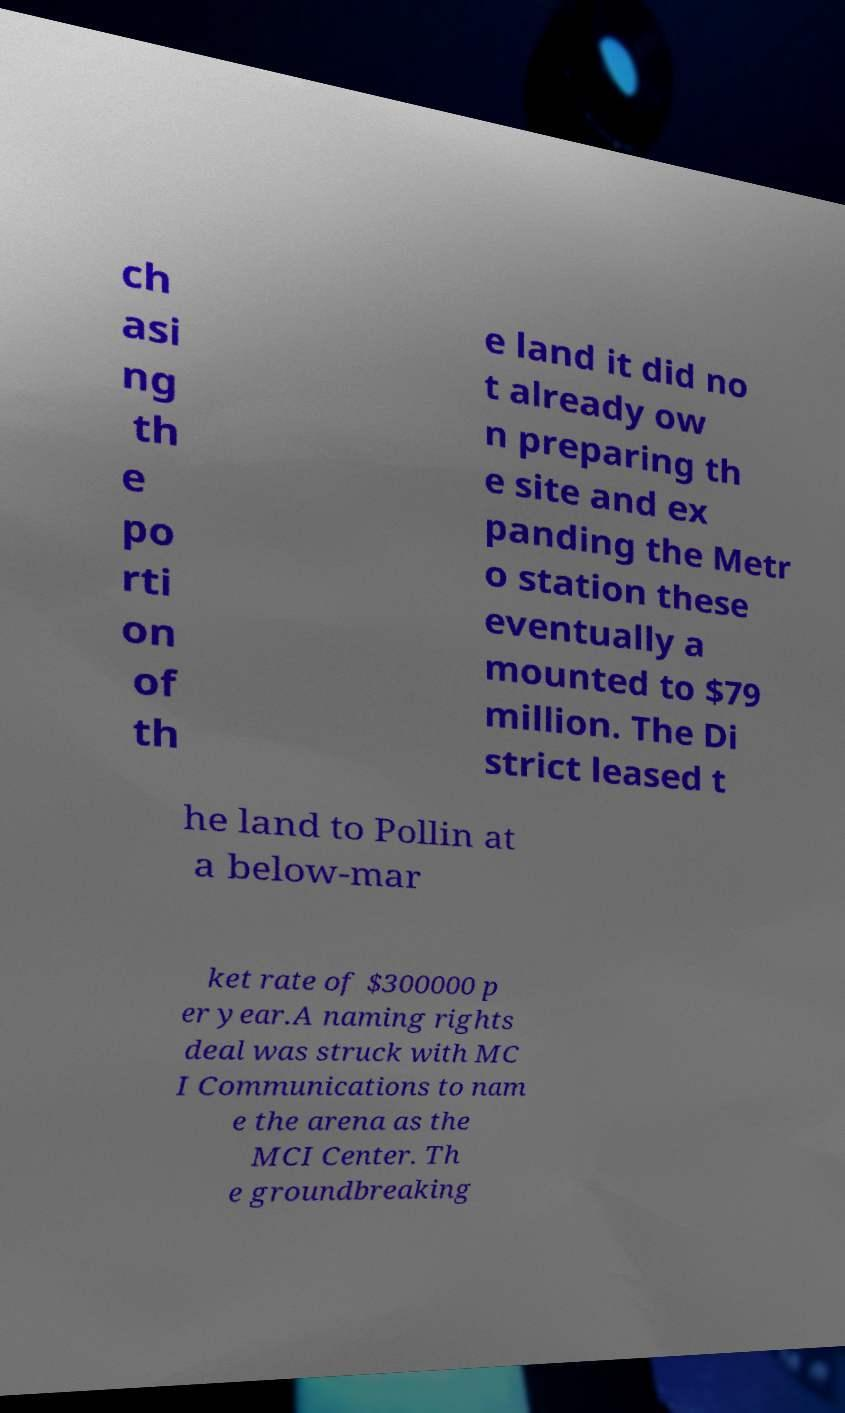Please read and relay the text visible in this image. What does it say? ch asi ng th e po rti on of th e land it did no t already ow n preparing th e site and ex panding the Metr o station these eventually a mounted to $79 million. The Di strict leased t he land to Pollin at a below-mar ket rate of $300000 p er year.A naming rights deal was struck with MC I Communications to nam e the arena as the MCI Center. Th e groundbreaking 